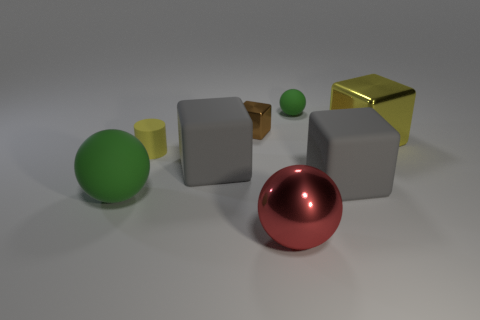Are there any tiny green rubber things to the right of the brown block?
Provide a succinct answer. Yes. Do the tiny object that is to the right of the brown cube and the red object have the same shape?
Ensure brevity in your answer.  Yes. There is a thing that is the same color as the rubber cylinder; what is it made of?
Give a very brief answer. Metal. How many rubber spheres are the same color as the big metal sphere?
Ensure brevity in your answer.  0. There is a tiny object left of the big gray matte object that is left of the small green matte thing; what shape is it?
Offer a terse response. Cylinder. Are there any other matte things that have the same shape as the large green thing?
Your response must be concise. Yes. Does the large matte sphere have the same color as the matte ball behind the tiny brown metal thing?
Provide a succinct answer. Yes. What is the size of the shiny block that is the same color as the small rubber cylinder?
Make the answer very short. Large. Is there another ball that has the same size as the metallic sphere?
Ensure brevity in your answer.  Yes. Does the small brown block have the same material as the big ball that is on the right side of the tiny yellow rubber cylinder?
Your answer should be very brief. Yes. 